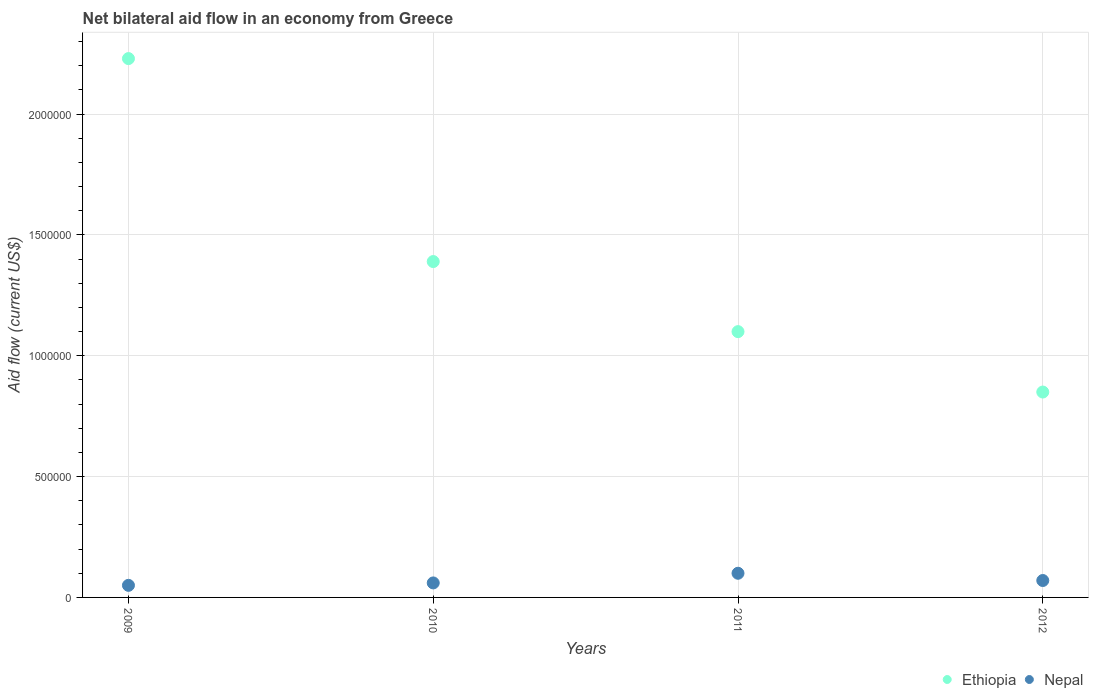How many different coloured dotlines are there?
Provide a succinct answer. 2. Is the number of dotlines equal to the number of legend labels?
Offer a terse response. Yes. What is the net bilateral aid flow in Ethiopia in 2009?
Provide a short and direct response. 2.23e+06. Across all years, what is the maximum net bilateral aid flow in Ethiopia?
Your answer should be very brief. 2.23e+06. Across all years, what is the minimum net bilateral aid flow in Ethiopia?
Offer a terse response. 8.50e+05. In which year was the net bilateral aid flow in Nepal maximum?
Ensure brevity in your answer.  2011. In which year was the net bilateral aid flow in Nepal minimum?
Offer a terse response. 2009. What is the total net bilateral aid flow in Ethiopia in the graph?
Ensure brevity in your answer.  5.57e+06. What is the difference between the net bilateral aid flow in Ethiopia in 2010 and that in 2012?
Keep it short and to the point. 5.40e+05. What is the difference between the net bilateral aid flow in Ethiopia in 2009 and the net bilateral aid flow in Nepal in 2012?
Provide a short and direct response. 2.16e+06. In the year 2010, what is the difference between the net bilateral aid flow in Nepal and net bilateral aid flow in Ethiopia?
Offer a terse response. -1.33e+06. Is the net bilateral aid flow in Ethiopia in 2010 less than that in 2012?
Provide a succinct answer. No. What is the difference between the highest and the second highest net bilateral aid flow in Nepal?
Provide a succinct answer. 3.00e+04. What is the difference between the highest and the lowest net bilateral aid flow in Ethiopia?
Give a very brief answer. 1.38e+06. In how many years, is the net bilateral aid flow in Nepal greater than the average net bilateral aid flow in Nepal taken over all years?
Ensure brevity in your answer.  1. Is the sum of the net bilateral aid flow in Ethiopia in 2009 and 2012 greater than the maximum net bilateral aid flow in Nepal across all years?
Keep it short and to the point. Yes. Is the net bilateral aid flow in Nepal strictly greater than the net bilateral aid flow in Ethiopia over the years?
Provide a succinct answer. No. What is the difference between two consecutive major ticks on the Y-axis?
Offer a terse response. 5.00e+05. Does the graph contain any zero values?
Provide a succinct answer. No. Does the graph contain grids?
Ensure brevity in your answer.  Yes. Where does the legend appear in the graph?
Ensure brevity in your answer.  Bottom right. How are the legend labels stacked?
Make the answer very short. Horizontal. What is the title of the graph?
Make the answer very short. Net bilateral aid flow in an economy from Greece. Does "Lithuania" appear as one of the legend labels in the graph?
Your response must be concise. No. What is the Aid flow (current US$) of Ethiopia in 2009?
Give a very brief answer. 2.23e+06. What is the Aid flow (current US$) in Nepal in 2009?
Your response must be concise. 5.00e+04. What is the Aid flow (current US$) of Ethiopia in 2010?
Ensure brevity in your answer.  1.39e+06. What is the Aid flow (current US$) in Nepal in 2010?
Your response must be concise. 6.00e+04. What is the Aid flow (current US$) in Ethiopia in 2011?
Your response must be concise. 1.10e+06. What is the Aid flow (current US$) in Ethiopia in 2012?
Offer a very short reply. 8.50e+05. What is the Aid flow (current US$) in Nepal in 2012?
Keep it short and to the point. 7.00e+04. Across all years, what is the maximum Aid flow (current US$) of Ethiopia?
Provide a short and direct response. 2.23e+06. Across all years, what is the minimum Aid flow (current US$) of Ethiopia?
Keep it short and to the point. 8.50e+05. What is the total Aid flow (current US$) of Ethiopia in the graph?
Your answer should be very brief. 5.57e+06. What is the total Aid flow (current US$) in Nepal in the graph?
Provide a short and direct response. 2.80e+05. What is the difference between the Aid flow (current US$) of Ethiopia in 2009 and that in 2010?
Offer a very short reply. 8.40e+05. What is the difference between the Aid flow (current US$) of Ethiopia in 2009 and that in 2011?
Give a very brief answer. 1.13e+06. What is the difference between the Aid flow (current US$) in Nepal in 2009 and that in 2011?
Offer a terse response. -5.00e+04. What is the difference between the Aid flow (current US$) of Ethiopia in 2009 and that in 2012?
Ensure brevity in your answer.  1.38e+06. What is the difference between the Aid flow (current US$) in Nepal in 2009 and that in 2012?
Ensure brevity in your answer.  -2.00e+04. What is the difference between the Aid flow (current US$) of Ethiopia in 2010 and that in 2011?
Give a very brief answer. 2.90e+05. What is the difference between the Aid flow (current US$) of Nepal in 2010 and that in 2011?
Provide a succinct answer. -4.00e+04. What is the difference between the Aid flow (current US$) in Ethiopia in 2010 and that in 2012?
Offer a terse response. 5.40e+05. What is the difference between the Aid flow (current US$) of Ethiopia in 2011 and that in 2012?
Give a very brief answer. 2.50e+05. What is the difference between the Aid flow (current US$) in Ethiopia in 2009 and the Aid flow (current US$) in Nepal in 2010?
Make the answer very short. 2.17e+06. What is the difference between the Aid flow (current US$) of Ethiopia in 2009 and the Aid flow (current US$) of Nepal in 2011?
Offer a very short reply. 2.13e+06. What is the difference between the Aid flow (current US$) in Ethiopia in 2009 and the Aid flow (current US$) in Nepal in 2012?
Provide a short and direct response. 2.16e+06. What is the difference between the Aid flow (current US$) of Ethiopia in 2010 and the Aid flow (current US$) of Nepal in 2011?
Your response must be concise. 1.29e+06. What is the difference between the Aid flow (current US$) in Ethiopia in 2010 and the Aid flow (current US$) in Nepal in 2012?
Offer a very short reply. 1.32e+06. What is the difference between the Aid flow (current US$) in Ethiopia in 2011 and the Aid flow (current US$) in Nepal in 2012?
Ensure brevity in your answer.  1.03e+06. What is the average Aid flow (current US$) of Ethiopia per year?
Ensure brevity in your answer.  1.39e+06. What is the average Aid flow (current US$) in Nepal per year?
Provide a succinct answer. 7.00e+04. In the year 2009, what is the difference between the Aid flow (current US$) of Ethiopia and Aid flow (current US$) of Nepal?
Offer a very short reply. 2.18e+06. In the year 2010, what is the difference between the Aid flow (current US$) in Ethiopia and Aid flow (current US$) in Nepal?
Your answer should be compact. 1.33e+06. In the year 2011, what is the difference between the Aid flow (current US$) in Ethiopia and Aid flow (current US$) in Nepal?
Your answer should be compact. 1.00e+06. In the year 2012, what is the difference between the Aid flow (current US$) in Ethiopia and Aid flow (current US$) in Nepal?
Your answer should be very brief. 7.80e+05. What is the ratio of the Aid flow (current US$) of Ethiopia in 2009 to that in 2010?
Offer a very short reply. 1.6. What is the ratio of the Aid flow (current US$) of Ethiopia in 2009 to that in 2011?
Offer a terse response. 2.03. What is the ratio of the Aid flow (current US$) of Nepal in 2009 to that in 2011?
Your answer should be very brief. 0.5. What is the ratio of the Aid flow (current US$) of Ethiopia in 2009 to that in 2012?
Provide a short and direct response. 2.62. What is the ratio of the Aid flow (current US$) of Nepal in 2009 to that in 2012?
Keep it short and to the point. 0.71. What is the ratio of the Aid flow (current US$) of Ethiopia in 2010 to that in 2011?
Ensure brevity in your answer.  1.26. What is the ratio of the Aid flow (current US$) of Nepal in 2010 to that in 2011?
Ensure brevity in your answer.  0.6. What is the ratio of the Aid flow (current US$) of Ethiopia in 2010 to that in 2012?
Your response must be concise. 1.64. What is the ratio of the Aid flow (current US$) in Nepal in 2010 to that in 2012?
Give a very brief answer. 0.86. What is the ratio of the Aid flow (current US$) in Ethiopia in 2011 to that in 2012?
Give a very brief answer. 1.29. What is the ratio of the Aid flow (current US$) of Nepal in 2011 to that in 2012?
Keep it short and to the point. 1.43. What is the difference between the highest and the second highest Aid flow (current US$) of Ethiopia?
Provide a succinct answer. 8.40e+05. What is the difference between the highest and the second highest Aid flow (current US$) of Nepal?
Keep it short and to the point. 3.00e+04. What is the difference between the highest and the lowest Aid flow (current US$) of Ethiopia?
Offer a terse response. 1.38e+06. 